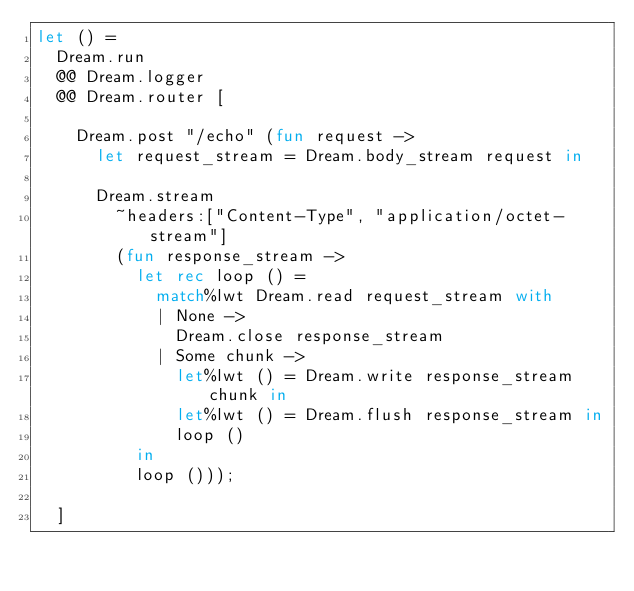<code> <loc_0><loc_0><loc_500><loc_500><_OCaml_>let () =
  Dream.run
  @@ Dream.logger
  @@ Dream.router [

    Dream.post "/echo" (fun request ->
      let request_stream = Dream.body_stream request in

      Dream.stream
        ~headers:["Content-Type", "application/octet-stream"]
        (fun response_stream ->
          let rec loop () =
            match%lwt Dream.read request_stream with
            | None ->
              Dream.close response_stream
            | Some chunk ->
              let%lwt () = Dream.write response_stream chunk in
              let%lwt () = Dream.flush response_stream in
              loop ()
          in
          loop ()));

  ]
</code> 